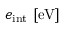<formula> <loc_0><loc_0><loc_500><loc_500>e _ { i n t } \ [ e V ]</formula> 